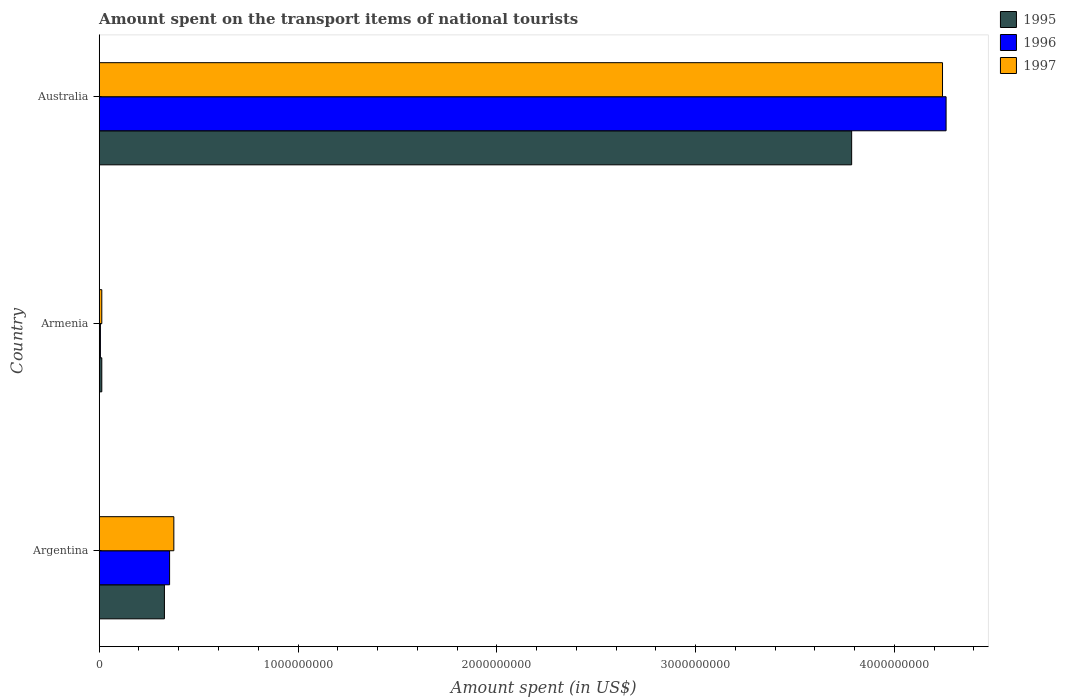How many groups of bars are there?
Your response must be concise. 3. Are the number of bars per tick equal to the number of legend labels?
Your answer should be very brief. Yes. Are the number of bars on each tick of the Y-axis equal?
Make the answer very short. Yes. How many bars are there on the 2nd tick from the top?
Keep it short and to the point. 3. What is the label of the 2nd group of bars from the top?
Your answer should be very brief. Armenia. What is the amount spent on the transport items of national tourists in 1995 in Armenia?
Make the answer very short. 1.30e+07. Across all countries, what is the maximum amount spent on the transport items of national tourists in 1997?
Provide a short and direct response. 4.24e+09. Across all countries, what is the minimum amount spent on the transport items of national tourists in 1997?
Give a very brief answer. 1.30e+07. In which country was the amount spent on the transport items of national tourists in 1997 minimum?
Offer a very short reply. Armenia. What is the total amount spent on the transport items of national tourists in 1997 in the graph?
Your answer should be very brief. 4.63e+09. What is the difference between the amount spent on the transport items of national tourists in 1997 in Armenia and that in Australia?
Provide a succinct answer. -4.23e+09. What is the difference between the amount spent on the transport items of national tourists in 1995 in Argentina and the amount spent on the transport items of national tourists in 1997 in Armenia?
Your answer should be compact. 3.15e+08. What is the average amount spent on the transport items of national tourists in 1995 per country?
Provide a succinct answer. 1.38e+09. What is the difference between the amount spent on the transport items of national tourists in 1996 and amount spent on the transport items of national tourists in 1995 in Australia?
Provide a short and direct response. 4.75e+08. In how many countries, is the amount spent on the transport items of national tourists in 1996 greater than 3000000000 US$?
Your answer should be very brief. 1. What is the ratio of the amount spent on the transport items of national tourists in 1995 in Argentina to that in Australia?
Give a very brief answer. 0.09. Is the amount spent on the transport items of national tourists in 1997 in Armenia less than that in Australia?
Provide a short and direct response. Yes. What is the difference between the highest and the second highest amount spent on the transport items of national tourists in 1995?
Your response must be concise. 3.46e+09. What is the difference between the highest and the lowest amount spent on the transport items of national tourists in 1997?
Keep it short and to the point. 4.23e+09. What does the 1st bar from the top in Armenia represents?
Ensure brevity in your answer.  1997. What does the 3rd bar from the bottom in Armenia represents?
Make the answer very short. 1997. How many bars are there?
Your answer should be compact. 9. Are all the bars in the graph horizontal?
Your response must be concise. Yes. What is the difference between two consecutive major ticks on the X-axis?
Ensure brevity in your answer.  1.00e+09. How many legend labels are there?
Your answer should be very brief. 3. How are the legend labels stacked?
Provide a short and direct response. Vertical. What is the title of the graph?
Offer a terse response. Amount spent on the transport items of national tourists. Does "1967" appear as one of the legend labels in the graph?
Offer a very short reply. No. What is the label or title of the X-axis?
Provide a succinct answer. Amount spent (in US$). What is the Amount spent (in US$) in 1995 in Argentina?
Offer a terse response. 3.28e+08. What is the Amount spent (in US$) in 1996 in Argentina?
Your answer should be very brief. 3.54e+08. What is the Amount spent (in US$) of 1997 in Argentina?
Keep it short and to the point. 3.75e+08. What is the Amount spent (in US$) of 1995 in Armenia?
Provide a succinct answer. 1.30e+07. What is the Amount spent (in US$) of 1997 in Armenia?
Your response must be concise. 1.30e+07. What is the Amount spent (in US$) of 1995 in Australia?
Offer a terse response. 3.78e+09. What is the Amount spent (in US$) in 1996 in Australia?
Make the answer very short. 4.26e+09. What is the Amount spent (in US$) of 1997 in Australia?
Ensure brevity in your answer.  4.24e+09. Across all countries, what is the maximum Amount spent (in US$) in 1995?
Offer a very short reply. 3.78e+09. Across all countries, what is the maximum Amount spent (in US$) in 1996?
Make the answer very short. 4.26e+09. Across all countries, what is the maximum Amount spent (in US$) in 1997?
Give a very brief answer. 4.24e+09. Across all countries, what is the minimum Amount spent (in US$) of 1995?
Keep it short and to the point. 1.30e+07. Across all countries, what is the minimum Amount spent (in US$) in 1997?
Give a very brief answer. 1.30e+07. What is the total Amount spent (in US$) of 1995 in the graph?
Provide a succinct answer. 4.13e+09. What is the total Amount spent (in US$) in 1996 in the graph?
Offer a very short reply. 4.62e+09. What is the total Amount spent (in US$) of 1997 in the graph?
Offer a very short reply. 4.63e+09. What is the difference between the Amount spent (in US$) in 1995 in Argentina and that in Armenia?
Make the answer very short. 3.15e+08. What is the difference between the Amount spent (in US$) of 1996 in Argentina and that in Armenia?
Provide a succinct answer. 3.48e+08. What is the difference between the Amount spent (in US$) of 1997 in Argentina and that in Armenia?
Your answer should be compact. 3.62e+08. What is the difference between the Amount spent (in US$) of 1995 in Argentina and that in Australia?
Keep it short and to the point. -3.46e+09. What is the difference between the Amount spent (in US$) in 1996 in Argentina and that in Australia?
Provide a succinct answer. -3.91e+09. What is the difference between the Amount spent (in US$) in 1997 in Argentina and that in Australia?
Ensure brevity in your answer.  -3.87e+09. What is the difference between the Amount spent (in US$) in 1995 in Armenia and that in Australia?
Your answer should be very brief. -3.77e+09. What is the difference between the Amount spent (in US$) in 1996 in Armenia and that in Australia?
Offer a very short reply. -4.25e+09. What is the difference between the Amount spent (in US$) in 1997 in Armenia and that in Australia?
Make the answer very short. -4.23e+09. What is the difference between the Amount spent (in US$) of 1995 in Argentina and the Amount spent (in US$) of 1996 in Armenia?
Make the answer very short. 3.22e+08. What is the difference between the Amount spent (in US$) in 1995 in Argentina and the Amount spent (in US$) in 1997 in Armenia?
Ensure brevity in your answer.  3.15e+08. What is the difference between the Amount spent (in US$) of 1996 in Argentina and the Amount spent (in US$) of 1997 in Armenia?
Offer a very short reply. 3.41e+08. What is the difference between the Amount spent (in US$) in 1995 in Argentina and the Amount spent (in US$) in 1996 in Australia?
Offer a terse response. -3.93e+09. What is the difference between the Amount spent (in US$) of 1995 in Argentina and the Amount spent (in US$) of 1997 in Australia?
Keep it short and to the point. -3.91e+09. What is the difference between the Amount spent (in US$) in 1996 in Argentina and the Amount spent (in US$) in 1997 in Australia?
Provide a succinct answer. -3.89e+09. What is the difference between the Amount spent (in US$) in 1995 in Armenia and the Amount spent (in US$) in 1996 in Australia?
Offer a very short reply. -4.25e+09. What is the difference between the Amount spent (in US$) of 1995 in Armenia and the Amount spent (in US$) of 1997 in Australia?
Your response must be concise. -4.23e+09. What is the difference between the Amount spent (in US$) of 1996 in Armenia and the Amount spent (in US$) of 1997 in Australia?
Keep it short and to the point. -4.24e+09. What is the average Amount spent (in US$) of 1995 per country?
Provide a succinct answer. 1.38e+09. What is the average Amount spent (in US$) in 1996 per country?
Provide a succinct answer. 1.54e+09. What is the average Amount spent (in US$) in 1997 per country?
Provide a succinct answer. 1.54e+09. What is the difference between the Amount spent (in US$) in 1995 and Amount spent (in US$) in 1996 in Argentina?
Offer a very short reply. -2.60e+07. What is the difference between the Amount spent (in US$) in 1995 and Amount spent (in US$) in 1997 in Argentina?
Offer a terse response. -4.74e+07. What is the difference between the Amount spent (in US$) of 1996 and Amount spent (in US$) of 1997 in Argentina?
Your response must be concise. -2.14e+07. What is the difference between the Amount spent (in US$) in 1995 and Amount spent (in US$) in 1997 in Armenia?
Keep it short and to the point. 0. What is the difference between the Amount spent (in US$) of 1996 and Amount spent (in US$) of 1997 in Armenia?
Offer a terse response. -7.00e+06. What is the difference between the Amount spent (in US$) of 1995 and Amount spent (in US$) of 1996 in Australia?
Offer a very short reply. -4.75e+08. What is the difference between the Amount spent (in US$) in 1995 and Amount spent (in US$) in 1997 in Australia?
Keep it short and to the point. -4.57e+08. What is the difference between the Amount spent (in US$) in 1996 and Amount spent (in US$) in 1997 in Australia?
Provide a succinct answer. 1.80e+07. What is the ratio of the Amount spent (in US$) in 1995 in Argentina to that in Armenia?
Provide a short and direct response. 25.23. What is the ratio of the Amount spent (in US$) in 1997 in Argentina to that in Armenia?
Offer a terse response. 28.88. What is the ratio of the Amount spent (in US$) in 1995 in Argentina to that in Australia?
Make the answer very short. 0.09. What is the ratio of the Amount spent (in US$) of 1996 in Argentina to that in Australia?
Your answer should be compact. 0.08. What is the ratio of the Amount spent (in US$) in 1997 in Argentina to that in Australia?
Your answer should be compact. 0.09. What is the ratio of the Amount spent (in US$) of 1995 in Armenia to that in Australia?
Offer a terse response. 0. What is the ratio of the Amount spent (in US$) in 1996 in Armenia to that in Australia?
Offer a terse response. 0. What is the ratio of the Amount spent (in US$) of 1997 in Armenia to that in Australia?
Keep it short and to the point. 0. What is the difference between the highest and the second highest Amount spent (in US$) of 1995?
Provide a succinct answer. 3.46e+09. What is the difference between the highest and the second highest Amount spent (in US$) in 1996?
Ensure brevity in your answer.  3.91e+09. What is the difference between the highest and the second highest Amount spent (in US$) in 1997?
Your answer should be very brief. 3.87e+09. What is the difference between the highest and the lowest Amount spent (in US$) of 1995?
Your response must be concise. 3.77e+09. What is the difference between the highest and the lowest Amount spent (in US$) in 1996?
Provide a succinct answer. 4.25e+09. What is the difference between the highest and the lowest Amount spent (in US$) in 1997?
Provide a short and direct response. 4.23e+09. 